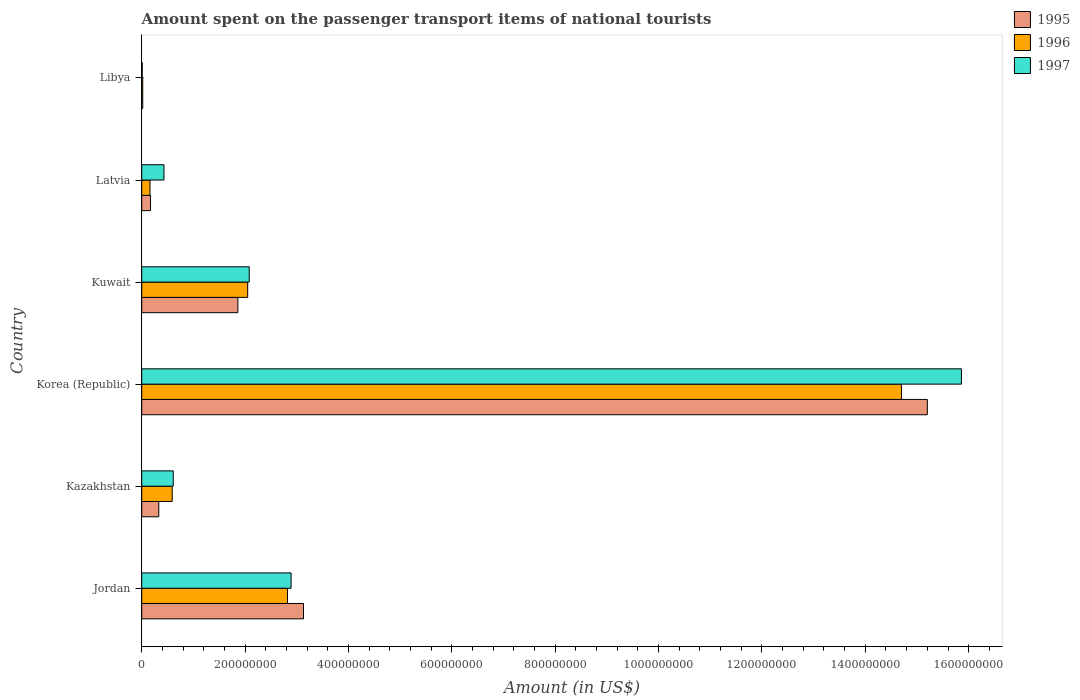How many groups of bars are there?
Make the answer very short. 6. How many bars are there on the 5th tick from the top?
Offer a terse response. 3. What is the label of the 5th group of bars from the top?
Offer a terse response. Kazakhstan. What is the amount spent on the passenger transport items of national tourists in 1997 in Korea (Republic)?
Offer a very short reply. 1.59e+09. Across all countries, what is the maximum amount spent on the passenger transport items of national tourists in 1995?
Your response must be concise. 1.52e+09. Across all countries, what is the minimum amount spent on the passenger transport items of national tourists in 1995?
Provide a short and direct response. 2.00e+06. In which country was the amount spent on the passenger transport items of national tourists in 1996 maximum?
Your response must be concise. Korea (Republic). In which country was the amount spent on the passenger transport items of national tourists in 1996 minimum?
Give a very brief answer. Libya. What is the total amount spent on the passenger transport items of national tourists in 1997 in the graph?
Provide a short and direct response. 2.19e+09. What is the difference between the amount spent on the passenger transport items of national tourists in 1996 in Jordan and that in Libya?
Give a very brief answer. 2.80e+08. What is the difference between the amount spent on the passenger transport items of national tourists in 1997 in Kazakhstan and the amount spent on the passenger transport items of national tourists in 1995 in Libya?
Your answer should be compact. 5.90e+07. What is the average amount spent on the passenger transport items of national tourists in 1997 per country?
Your response must be concise. 3.65e+08. What is the difference between the amount spent on the passenger transport items of national tourists in 1997 and amount spent on the passenger transport items of national tourists in 1995 in Kazakhstan?
Ensure brevity in your answer.  2.80e+07. What is the ratio of the amount spent on the passenger transport items of national tourists in 1997 in Korea (Republic) to that in Kuwait?
Provide a succinct answer. 7.62. What is the difference between the highest and the second highest amount spent on the passenger transport items of national tourists in 1996?
Your answer should be very brief. 1.19e+09. What is the difference between the highest and the lowest amount spent on the passenger transport items of national tourists in 1995?
Give a very brief answer. 1.52e+09. Is it the case that in every country, the sum of the amount spent on the passenger transport items of national tourists in 1996 and amount spent on the passenger transport items of national tourists in 1995 is greater than the amount spent on the passenger transport items of national tourists in 1997?
Your answer should be compact. No. How many bars are there?
Ensure brevity in your answer.  18. How many countries are there in the graph?
Offer a very short reply. 6. What is the difference between two consecutive major ticks on the X-axis?
Offer a very short reply. 2.00e+08. Are the values on the major ticks of X-axis written in scientific E-notation?
Your response must be concise. No. Does the graph contain any zero values?
Offer a terse response. No. Where does the legend appear in the graph?
Your answer should be compact. Top right. How are the legend labels stacked?
Offer a terse response. Vertical. What is the title of the graph?
Provide a succinct answer. Amount spent on the passenger transport items of national tourists. Does "1982" appear as one of the legend labels in the graph?
Your answer should be very brief. No. What is the label or title of the X-axis?
Your response must be concise. Amount (in US$). What is the label or title of the Y-axis?
Offer a very short reply. Country. What is the Amount (in US$) of 1995 in Jordan?
Ensure brevity in your answer.  3.13e+08. What is the Amount (in US$) of 1996 in Jordan?
Give a very brief answer. 2.82e+08. What is the Amount (in US$) of 1997 in Jordan?
Offer a terse response. 2.89e+08. What is the Amount (in US$) in 1995 in Kazakhstan?
Give a very brief answer. 3.30e+07. What is the Amount (in US$) of 1996 in Kazakhstan?
Offer a very short reply. 5.90e+07. What is the Amount (in US$) of 1997 in Kazakhstan?
Your response must be concise. 6.10e+07. What is the Amount (in US$) in 1995 in Korea (Republic)?
Ensure brevity in your answer.  1.52e+09. What is the Amount (in US$) of 1996 in Korea (Republic)?
Keep it short and to the point. 1.47e+09. What is the Amount (in US$) of 1997 in Korea (Republic)?
Keep it short and to the point. 1.59e+09. What is the Amount (in US$) of 1995 in Kuwait?
Your answer should be very brief. 1.86e+08. What is the Amount (in US$) in 1996 in Kuwait?
Offer a terse response. 2.05e+08. What is the Amount (in US$) of 1997 in Kuwait?
Offer a very short reply. 2.08e+08. What is the Amount (in US$) in 1995 in Latvia?
Your answer should be compact. 1.70e+07. What is the Amount (in US$) in 1996 in Latvia?
Provide a short and direct response. 1.60e+07. What is the Amount (in US$) of 1997 in Latvia?
Ensure brevity in your answer.  4.30e+07. What is the Amount (in US$) of 1995 in Libya?
Offer a terse response. 2.00e+06. What is the Amount (in US$) in 1997 in Libya?
Provide a short and direct response. 1.00e+06. Across all countries, what is the maximum Amount (in US$) of 1995?
Offer a terse response. 1.52e+09. Across all countries, what is the maximum Amount (in US$) in 1996?
Provide a short and direct response. 1.47e+09. Across all countries, what is the maximum Amount (in US$) of 1997?
Provide a succinct answer. 1.59e+09. Across all countries, what is the minimum Amount (in US$) in 1995?
Offer a very short reply. 2.00e+06. Across all countries, what is the minimum Amount (in US$) of 1996?
Give a very brief answer. 2.00e+06. What is the total Amount (in US$) in 1995 in the graph?
Keep it short and to the point. 2.07e+09. What is the total Amount (in US$) of 1996 in the graph?
Your response must be concise. 2.03e+09. What is the total Amount (in US$) of 1997 in the graph?
Make the answer very short. 2.19e+09. What is the difference between the Amount (in US$) in 1995 in Jordan and that in Kazakhstan?
Your answer should be compact. 2.80e+08. What is the difference between the Amount (in US$) in 1996 in Jordan and that in Kazakhstan?
Offer a terse response. 2.23e+08. What is the difference between the Amount (in US$) in 1997 in Jordan and that in Kazakhstan?
Offer a very short reply. 2.28e+08. What is the difference between the Amount (in US$) of 1995 in Jordan and that in Korea (Republic)?
Offer a very short reply. -1.21e+09. What is the difference between the Amount (in US$) in 1996 in Jordan and that in Korea (Republic)?
Your answer should be compact. -1.19e+09. What is the difference between the Amount (in US$) in 1997 in Jordan and that in Korea (Republic)?
Ensure brevity in your answer.  -1.30e+09. What is the difference between the Amount (in US$) in 1995 in Jordan and that in Kuwait?
Your answer should be very brief. 1.27e+08. What is the difference between the Amount (in US$) of 1996 in Jordan and that in Kuwait?
Provide a succinct answer. 7.70e+07. What is the difference between the Amount (in US$) in 1997 in Jordan and that in Kuwait?
Your answer should be compact. 8.10e+07. What is the difference between the Amount (in US$) in 1995 in Jordan and that in Latvia?
Your answer should be very brief. 2.96e+08. What is the difference between the Amount (in US$) of 1996 in Jordan and that in Latvia?
Your answer should be compact. 2.66e+08. What is the difference between the Amount (in US$) in 1997 in Jordan and that in Latvia?
Provide a short and direct response. 2.46e+08. What is the difference between the Amount (in US$) of 1995 in Jordan and that in Libya?
Make the answer very short. 3.11e+08. What is the difference between the Amount (in US$) of 1996 in Jordan and that in Libya?
Offer a terse response. 2.80e+08. What is the difference between the Amount (in US$) in 1997 in Jordan and that in Libya?
Ensure brevity in your answer.  2.88e+08. What is the difference between the Amount (in US$) in 1995 in Kazakhstan and that in Korea (Republic)?
Keep it short and to the point. -1.49e+09. What is the difference between the Amount (in US$) of 1996 in Kazakhstan and that in Korea (Republic)?
Make the answer very short. -1.41e+09. What is the difference between the Amount (in US$) of 1997 in Kazakhstan and that in Korea (Republic)?
Offer a terse response. -1.52e+09. What is the difference between the Amount (in US$) of 1995 in Kazakhstan and that in Kuwait?
Offer a very short reply. -1.53e+08. What is the difference between the Amount (in US$) in 1996 in Kazakhstan and that in Kuwait?
Give a very brief answer. -1.46e+08. What is the difference between the Amount (in US$) in 1997 in Kazakhstan and that in Kuwait?
Keep it short and to the point. -1.47e+08. What is the difference between the Amount (in US$) of 1995 in Kazakhstan and that in Latvia?
Make the answer very short. 1.60e+07. What is the difference between the Amount (in US$) of 1996 in Kazakhstan and that in Latvia?
Give a very brief answer. 4.30e+07. What is the difference between the Amount (in US$) of 1997 in Kazakhstan and that in Latvia?
Your response must be concise. 1.80e+07. What is the difference between the Amount (in US$) of 1995 in Kazakhstan and that in Libya?
Provide a short and direct response. 3.10e+07. What is the difference between the Amount (in US$) of 1996 in Kazakhstan and that in Libya?
Offer a very short reply. 5.70e+07. What is the difference between the Amount (in US$) in 1997 in Kazakhstan and that in Libya?
Ensure brevity in your answer.  6.00e+07. What is the difference between the Amount (in US$) of 1995 in Korea (Republic) and that in Kuwait?
Make the answer very short. 1.33e+09. What is the difference between the Amount (in US$) in 1996 in Korea (Republic) and that in Kuwait?
Your response must be concise. 1.26e+09. What is the difference between the Amount (in US$) in 1997 in Korea (Republic) and that in Kuwait?
Make the answer very short. 1.38e+09. What is the difference between the Amount (in US$) in 1995 in Korea (Republic) and that in Latvia?
Offer a very short reply. 1.50e+09. What is the difference between the Amount (in US$) of 1996 in Korea (Republic) and that in Latvia?
Provide a short and direct response. 1.45e+09. What is the difference between the Amount (in US$) of 1997 in Korea (Republic) and that in Latvia?
Give a very brief answer. 1.54e+09. What is the difference between the Amount (in US$) of 1995 in Korea (Republic) and that in Libya?
Offer a terse response. 1.52e+09. What is the difference between the Amount (in US$) of 1996 in Korea (Republic) and that in Libya?
Make the answer very short. 1.47e+09. What is the difference between the Amount (in US$) in 1997 in Korea (Republic) and that in Libya?
Ensure brevity in your answer.  1.58e+09. What is the difference between the Amount (in US$) in 1995 in Kuwait and that in Latvia?
Provide a succinct answer. 1.69e+08. What is the difference between the Amount (in US$) of 1996 in Kuwait and that in Latvia?
Keep it short and to the point. 1.89e+08. What is the difference between the Amount (in US$) of 1997 in Kuwait and that in Latvia?
Offer a very short reply. 1.65e+08. What is the difference between the Amount (in US$) in 1995 in Kuwait and that in Libya?
Ensure brevity in your answer.  1.84e+08. What is the difference between the Amount (in US$) of 1996 in Kuwait and that in Libya?
Provide a succinct answer. 2.03e+08. What is the difference between the Amount (in US$) of 1997 in Kuwait and that in Libya?
Offer a terse response. 2.07e+08. What is the difference between the Amount (in US$) in 1995 in Latvia and that in Libya?
Your answer should be very brief. 1.50e+07. What is the difference between the Amount (in US$) in 1996 in Latvia and that in Libya?
Your answer should be very brief. 1.40e+07. What is the difference between the Amount (in US$) of 1997 in Latvia and that in Libya?
Your answer should be compact. 4.20e+07. What is the difference between the Amount (in US$) in 1995 in Jordan and the Amount (in US$) in 1996 in Kazakhstan?
Your answer should be very brief. 2.54e+08. What is the difference between the Amount (in US$) of 1995 in Jordan and the Amount (in US$) of 1997 in Kazakhstan?
Ensure brevity in your answer.  2.52e+08. What is the difference between the Amount (in US$) in 1996 in Jordan and the Amount (in US$) in 1997 in Kazakhstan?
Provide a short and direct response. 2.21e+08. What is the difference between the Amount (in US$) in 1995 in Jordan and the Amount (in US$) in 1996 in Korea (Republic)?
Your answer should be compact. -1.16e+09. What is the difference between the Amount (in US$) in 1995 in Jordan and the Amount (in US$) in 1997 in Korea (Republic)?
Ensure brevity in your answer.  -1.27e+09. What is the difference between the Amount (in US$) in 1996 in Jordan and the Amount (in US$) in 1997 in Korea (Republic)?
Offer a terse response. -1.30e+09. What is the difference between the Amount (in US$) of 1995 in Jordan and the Amount (in US$) of 1996 in Kuwait?
Provide a short and direct response. 1.08e+08. What is the difference between the Amount (in US$) in 1995 in Jordan and the Amount (in US$) in 1997 in Kuwait?
Your answer should be compact. 1.05e+08. What is the difference between the Amount (in US$) of 1996 in Jordan and the Amount (in US$) of 1997 in Kuwait?
Your answer should be very brief. 7.40e+07. What is the difference between the Amount (in US$) in 1995 in Jordan and the Amount (in US$) in 1996 in Latvia?
Provide a succinct answer. 2.97e+08. What is the difference between the Amount (in US$) of 1995 in Jordan and the Amount (in US$) of 1997 in Latvia?
Provide a short and direct response. 2.70e+08. What is the difference between the Amount (in US$) in 1996 in Jordan and the Amount (in US$) in 1997 in Latvia?
Your response must be concise. 2.39e+08. What is the difference between the Amount (in US$) in 1995 in Jordan and the Amount (in US$) in 1996 in Libya?
Give a very brief answer. 3.11e+08. What is the difference between the Amount (in US$) of 1995 in Jordan and the Amount (in US$) of 1997 in Libya?
Your response must be concise. 3.12e+08. What is the difference between the Amount (in US$) in 1996 in Jordan and the Amount (in US$) in 1997 in Libya?
Ensure brevity in your answer.  2.81e+08. What is the difference between the Amount (in US$) in 1995 in Kazakhstan and the Amount (in US$) in 1996 in Korea (Republic)?
Offer a very short reply. -1.44e+09. What is the difference between the Amount (in US$) in 1995 in Kazakhstan and the Amount (in US$) in 1997 in Korea (Republic)?
Provide a short and direct response. -1.55e+09. What is the difference between the Amount (in US$) of 1996 in Kazakhstan and the Amount (in US$) of 1997 in Korea (Republic)?
Make the answer very short. -1.53e+09. What is the difference between the Amount (in US$) in 1995 in Kazakhstan and the Amount (in US$) in 1996 in Kuwait?
Your answer should be very brief. -1.72e+08. What is the difference between the Amount (in US$) in 1995 in Kazakhstan and the Amount (in US$) in 1997 in Kuwait?
Keep it short and to the point. -1.75e+08. What is the difference between the Amount (in US$) of 1996 in Kazakhstan and the Amount (in US$) of 1997 in Kuwait?
Offer a very short reply. -1.49e+08. What is the difference between the Amount (in US$) in 1995 in Kazakhstan and the Amount (in US$) in 1996 in Latvia?
Offer a terse response. 1.70e+07. What is the difference between the Amount (in US$) in 1995 in Kazakhstan and the Amount (in US$) in 1997 in Latvia?
Give a very brief answer. -1.00e+07. What is the difference between the Amount (in US$) in 1996 in Kazakhstan and the Amount (in US$) in 1997 in Latvia?
Your response must be concise. 1.60e+07. What is the difference between the Amount (in US$) in 1995 in Kazakhstan and the Amount (in US$) in 1996 in Libya?
Ensure brevity in your answer.  3.10e+07. What is the difference between the Amount (in US$) of 1995 in Kazakhstan and the Amount (in US$) of 1997 in Libya?
Your response must be concise. 3.20e+07. What is the difference between the Amount (in US$) of 1996 in Kazakhstan and the Amount (in US$) of 1997 in Libya?
Keep it short and to the point. 5.80e+07. What is the difference between the Amount (in US$) of 1995 in Korea (Republic) and the Amount (in US$) of 1996 in Kuwait?
Your response must be concise. 1.32e+09. What is the difference between the Amount (in US$) in 1995 in Korea (Republic) and the Amount (in US$) in 1997 in Kuwait?
Keep it short and to the point. 1.31e+09. What is the difference between the Amount (in US$) of 1996 in Korea (Republic) and the Amount (in US$) of 1997 in Kuwait?
Your answer should be very brief. 1.26e+09. What is the difference between the Amount (in US$) of 1995 in Korea (Republic) and the Amount (in US$) of 1996 in Latvia?
Make the answer very short. 1.50e+09. What is the difference between the Amount (in US$) of 1995 in Korea (Republic) and the Amount (in US$) of 1997 in Latvia?
Make the answer very short. 1.48e+09. What is the difference between the Amount (in US$) of 1996 in Korea (Republic) and the Amount (in US$) of 1997 in Latvia?
Offer a terse response. 1.43e+09. What is the difference between the Amount (in US$) in 1995 in Korea (Republic) and the Amount (in US$) in 1996 in Libya?
Your response must be concise. 1.52e+09. What is the difference between the Amount (in US$) of 1995 in Korea (Republic) and the Amount (in US$) of 1997 in Libya?
Give a very brief answer. 1.52e+09. What is the difference between the Amount (in US$) of 1996 in Korea (Republic) and the Amount (in US$) of 1997 in Libya?
Provide a short and direct response. 1.47e+09. What is the difference between the Amount (in US$) of 1995 in Kuwait and the Amount (in US$) of 1996 in Latvia?
Ensure brevity in your answer.  1.70e+08. What is the difference between the Amount (in US$) in 1995 in Kuwait and the Amount (in US$) in 1997 in Latvia?
Provide a succinct answer. 1.43e+08. What is the difference between the Amount (in US$) in 1996 in Kuwait and the Amount (in US$) in 1997 in Latvia?
Your answer should be compact. 1.62e+08. What is the difference between the Amount (in US$) of 1995 in Kuwait and the Amount (in US$) of 1996 in Libya?
Ensure brevity in your answer.  1.84e+08. What is the difference between the Amount (in US$) in 1995 in Kuwait and the Amount (in US$) in 1997 in Libya?
Ensure brevity in your answer.  1.85e+08. What is the difference between the Amount (in US$) of 1996 in Kuwait and the Amount (in US$) of 1997 in Libya?
Offer a very short reply. 2.04e+08. What is the difference between the Amount (in US$) of 1995 in Latvia and the Amount (in US$) of 1996 in Libya?
Provide a succinct answer. 1.50e+07. What is the difference between the Amount (in US$) of 1995 in Latvia and the Amount (in US$) of 1997 in Libya?
Make the answer very short. 1.60e+07. What is the difference between the Amount (in US$) of 1996 in Latvia and the Amount (in US$) of 1997 in Libya?
Offer a terse response. 1.50e+07. What is the average Amount (in US$) in 1995 per country?
Keep it short and to the point. 3.45e+08. What is the average Amount (in US$) of 1996 per country?
Offer a terse response. 3.39e+08. What is the average Amount (in US$) in 1997 per country?
Offer a very short reply. 3.65e+08. What is the difference between the Amount (in US$) in 1995 and Amount (in US$) in 1996 in Jordan?
Keep it short and to the point. 3.10e+07. What is the difference between the Amount (in US$) in 1995 and Amount (in US$) in 1997 in Jordan?
Give a very brief answer. 2.40e+07. What is the difference between the Amount (in US$) in 1996 and Amount (in US$) in 1997 in Jordan?
Provide a succinct answer. -7.00e+06. What is the difference between the Amount (in US$) of 1995 and Amount (in US$) of 1996 in Kazakhstan?
Make the answer very short. -2.60e+07. What is the difference between the Amount (in US$) of 1995 and Amount (in US$) of 1997 in Kazakhstan?
Offer a very short reply. -2.80e+07. What is the difference between the Amount (in US$) in 1995 and Amount (in US$) in 1997 in Korea (Republic)?
Offer a very short reply. -6.60e+07. What is the difference between the Amount (in US$) of 1996 and Amount (in US$) of 1997 in Korea (Republic)?
Offer a terse response. -1.16e+08. What is the difference between the Amount (in US$) in 1995 and Amount (in US$) in 1996 in Kuwait?
Provide a short and direct response. -1.90e+07. What is the difference between the Amount (in US$) of 1995 and Amount (in US$) of 1997 in Kuwait?
Offer a very short reply. -2.20e+07. What is the difference between the Amount (in US$) of 1996 and Amount (in US$) of 1997 in Kuwait?
Offer a very short reply. -3.00e+06. What is the difference between the Amount (in US$) of 1995 and Amount (in US$) of 1997 in Latvia?
Make the answer very short. -2.60e+07. What is the difference between the Amount (in US$) of 1996 and Amount (in US$) of 1997 in Latvia?
Give a very brief answer. -2.70e+07. What is the difference between the Amount (in US$) of 1995 and Amount (in US$) of 1997 in Libya?
Your answer should be compact. 1.00e+06. What is the ratio of the Amount (in US$) in 1995 in Jordan to that in Kazakhstan?
Offer a terse response. 9.48. What is the ratio of the Amount (in US$) in 1996 in Jordan to that in Kazakhstan?
Offer a terse response. 4.78. What is the ratio of the Amount (in US$) of 1997 in Jordan to that in Kazakhstan?
Make the answer very short. 4.74. What is the ratio of the Amount (in US$) of 1995 in Jordan to that in Korea (Republic)?
Your answer should be compact. 0.21. What is the ratio of the Amount (in US$) of 1996 in Jordan to that in Korea (Republic)?
Provide a succinct answer. 0.19. What is the ratio of the Amount (in US$) in 1997 in Jordan to that in Korea (Republic)?
Ensure brevity in your answer.  0.18. What is the ratio of the Amount (in US$) of 1995 in Jordan to that in Kuwait?
Give a very brief answer. 1.68. What is the ratio of the Amount (in US$) of 1996 in Jordan to that in Kuwait?
Make the answer very short. 1.38. What is the ratio of the Amount (in US$) of 1997 in Jordan to that in Kuwait?
Your answer should be very brief. 1.39. What is the ratio of the Amount (in US$) of 1995 in Jordan to that in Latvia?
Ensure brevity in your answer.  18.41. What is the ratio of the Amount (in US$) in 1996 in Jordan to that in Latvia?
Your response must be concise. 17.62. What is the ratio of the Amount (in US$) of 1997 in Jordan to that in Latvia?
Offer a very short reply. 6.72. What is the ratio of the Amount (in US$) in 1995 in Jordan to that in Libya?
Make the answer very short. 156.5. What is the ratio of the Amount (in US$) in 1996 in Jordan to that in Libya?
Provide a short and direct response. 141. What is the ratio of the Amount (in US$) of 1997 in Jordan to that in Libya?
Offer a very short reply. 289. What is the ratio of the Amount (in US$) of 1995 in Kazakhstan to that in Korea (Republic)?
Offer a very short reply. 0.02. What is the ratio of the Amount (in US$) in 1996 in Kazakhstan to that in Korea (Republic)?
Give a very brief answer. 0.04. What is the ratio of the Amount (in US$) in 1997 in Kazakhstan to that in Korea (Republic)?
Your response must be concise. 0.04. What is the ratio of the Amount (in US$) of 1995 in Kazakhstan to that in Kuwait?
Your answer should be compact. 0.18. What is the ratio of the Amount (in US$) of 1996 in Kazakhstan to that in Kuwait?
Ensure brevity in your answer.  0.29. What is the ratio of the Amount (in US$) in 1997 in Kazakhstan to that in Kuwait?
Your answer should be very brief. 0.29. What is the ratio of the Amount (in US$) in 1995 in Kazakhstan to that in Latvia?
Your response must be concise. 1.94. What is the ratio of the Amount (in US$) of 1996 in Kazakhstan to that in Latvia?
Your answer should be compact. 3.69. What is the ratio of the Amount (in US$) of 1997 in Kazakhstan to that in Latvia?
Give a very brief answer. 1.42. What is the ratio of the Amount (in US$) of 1996 in Kazakhstan to that in Libya?
Make the answer very short. 29.5. What is the ratio of the Amount (in US$) of 1997 in Kazakhstan to that in Libya?
Make the answer very short. 61. What is the ratio of the Amount (in US$) in 1995 in Korea (Republic) to that in Kuwait?
Your response must be concise. 8.17. What is the ratio of the Amount (in US$) of 1996 in Korea (Republic) to that in Kuwait?
Offer a very short reply. 7.17. What is the ratio of the Amount (in US$) of 1997 in Korea (Republic) to that in Kuwait?
Your answer should be very brief. 7.62. What is the ratio of the Amount (in US$) in 1995 in Korea (Republic) to that in Latvia?
Ensure brevity in your answer.  89.41. What is the ratio of the Amount (in US$) of 1996 in Korea (Republic) to that in Latvia?
Ensure brevity in your answer.  91.88. What is the ratio of the Amount (in US$) of 1997 in Korea (Republic) to that in Latvia?
Your answer should be compact. 36.88. What is the ratio of the Amount (in US$) in 1995 in Korea (Republic) to that in Libya?
Ensure brevity in your answer.  760. What is the ratio of the Amount (in US$) of 1996 in Korea (Republic) to that in Libya?
Offer a terse response. 735. What is the ratio of the Amount (in US$) in 1997 in Korea (Republic) to that in Libya?
Offer a terse response. 1586. What is the ratio of the Amount (in US$) of 1995 in Kuwait to that in Latvia?
Keep it short and to the point. 10.94. What is the ratio of the Amount (in US$) of 1996 in Kuwait to that in Latvia?
Your answer should be compact. 12.81. What is the ratio of the Amount (in US$) in 1997 in Kuwait to that in Latvia?
Provide a succinct answer. 4.84. What is the ratio of the Amount (in US$) in 1995 in Kuwait to that in Libya?
Provide a succinct answer. 93. What is the ratio of the Amount (in US$) in 1996 in Kuwait to that in Libya?
Your answer should be compact. 102.5. What is the ratio of the Amount (in US$) of 1997 in Kuwait to that in Libya?
Give a very brief answer. 208. What is the ratio of the Amount (in US$) of 1996 in Latvia to that in Libya?
Your answer should be compact. 8. What is the ratio of the Amount (in US$) in 1997 in Latvia to that in Libya?
Provide a succinct answer. 43. What is the difference between the highest and the second highest Amount (in US$) of 1995?
Give a very brief answer. 1.21e+09. What is the difference between the highest and the second highest Amount (in US$) in 1996?
Provide a succinct answer. 1.19e+09. What is the difference between the highest and the second highest Amount (in US$) of 1997?
Ensure brevity in your answer.  1.30e+09. What is the difference between the highest and the lowest Amount (in US$) in 1995?
Your response must be concise. 1.52e+09. What is the difference between the highest and the lowest Amount (in US$) in 1996?
Your answer should be compact. 1.47e+09. What is the difference between the highest and the lowest Amount (in US$) in 1997?
Give a very brief answer. 1.58e+09. 